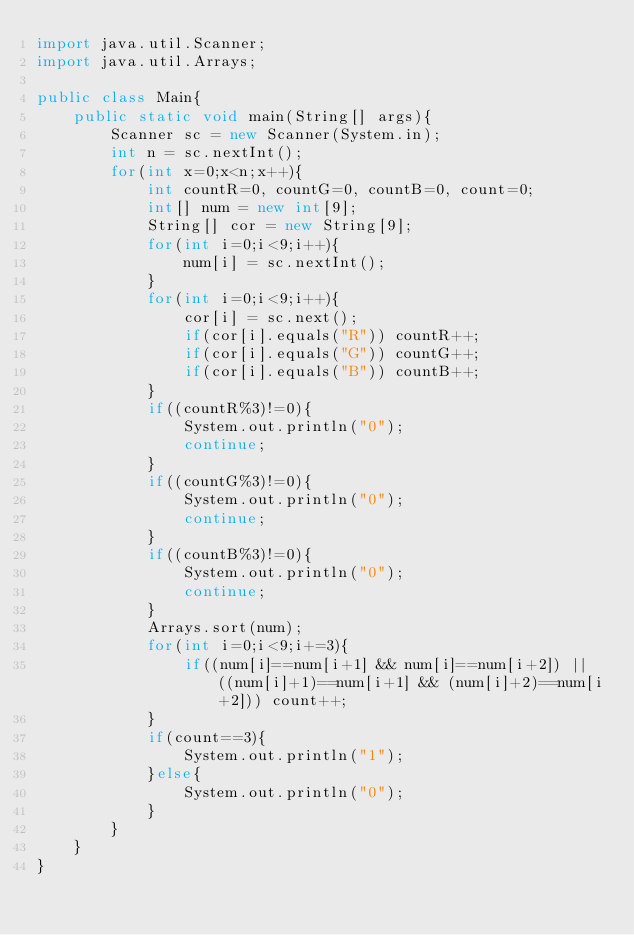<code> <loc_0><loc_0><loc_500><loc_500><_Java_>import java.util.Scanner;
import java.util.Arrays;

public class Main{
    public static void main(String[] args){
        Scanner sc = new Scanner(System.in);
        int n = sc.nextInt();
        for(int x=0;x<n;x++){
            int countR=0, countG=0, countB=0, count=0;
            int[] num = new int[9];
            String[] cor = new String[9];
            for(int i=0;i<9;i++){
                num[i] = sc.nextInt();
            }
            for(int i=0;i<9;i++){
                cor[i] = sc.next();
                if(cor[i].equals("R")) countR++;
                if(cor[i].equals("G")) countG++;
                if(cor[i].equals("B")) countB++;
            }
            if((countR%3)!=0){
                System.out.println("0");
                continue;
            }
            if((countG%3)!=0){
                System.out.println("0");
                continue;
            }
            if((countB%3)!=0){
                System.out.println("0");
                continue;
            }
            Arrays.sort(num);
            for(int i=0;i<9;i+=3){
                if((num[i]==num[i+1] && num[i]==num[i+2]) || ((num[i]+1)==num[i+1] && (num[i]+2)==num[i+2])) count++;
            }
            if(count==3){
                System.out.println("1");
            }else{
                System.out.println("0");
            }
        }
    }
}
</code> 